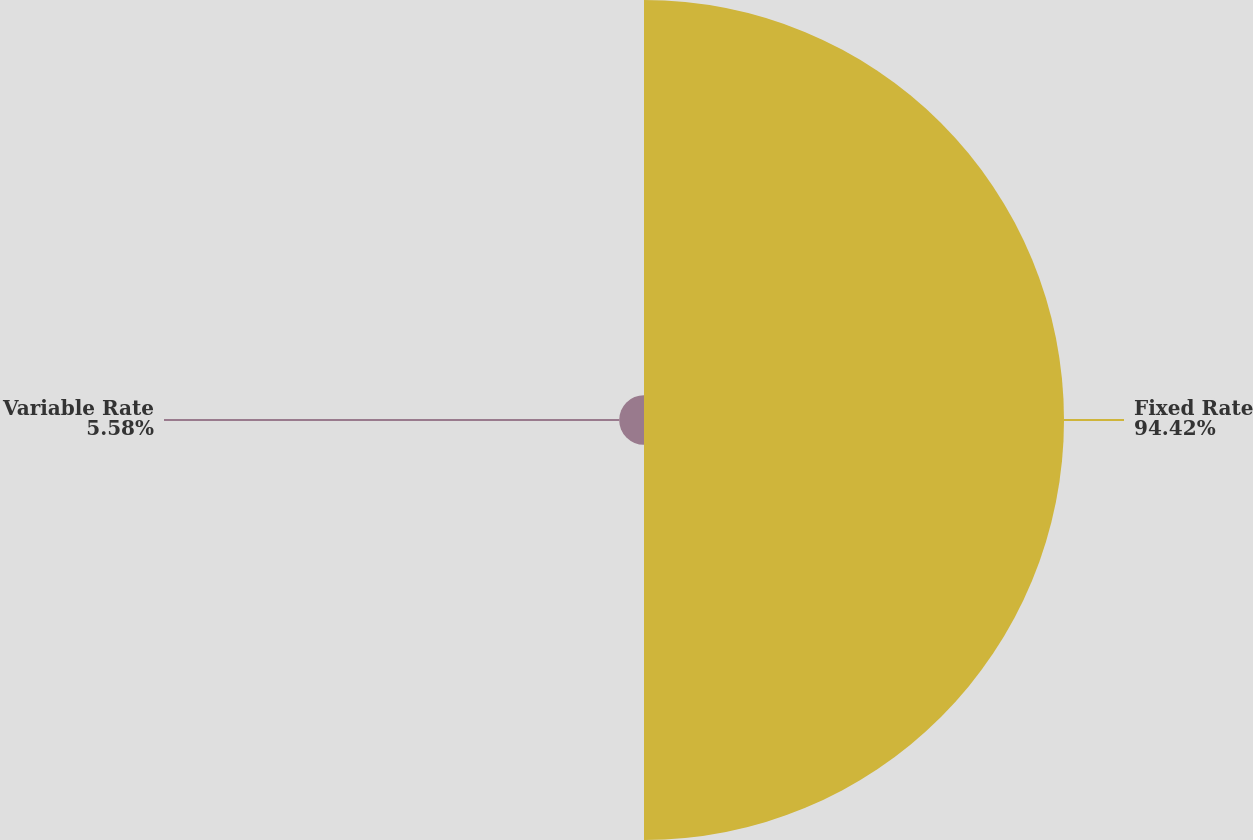Convert chart. <chart><loc_0><loc_0><loc_500><loc_500><pie_chart><fcel>Fixed Rate<fcel>Variable Rate<nl><fcel>94.42%<fcel>5.58%<nl></chart> 